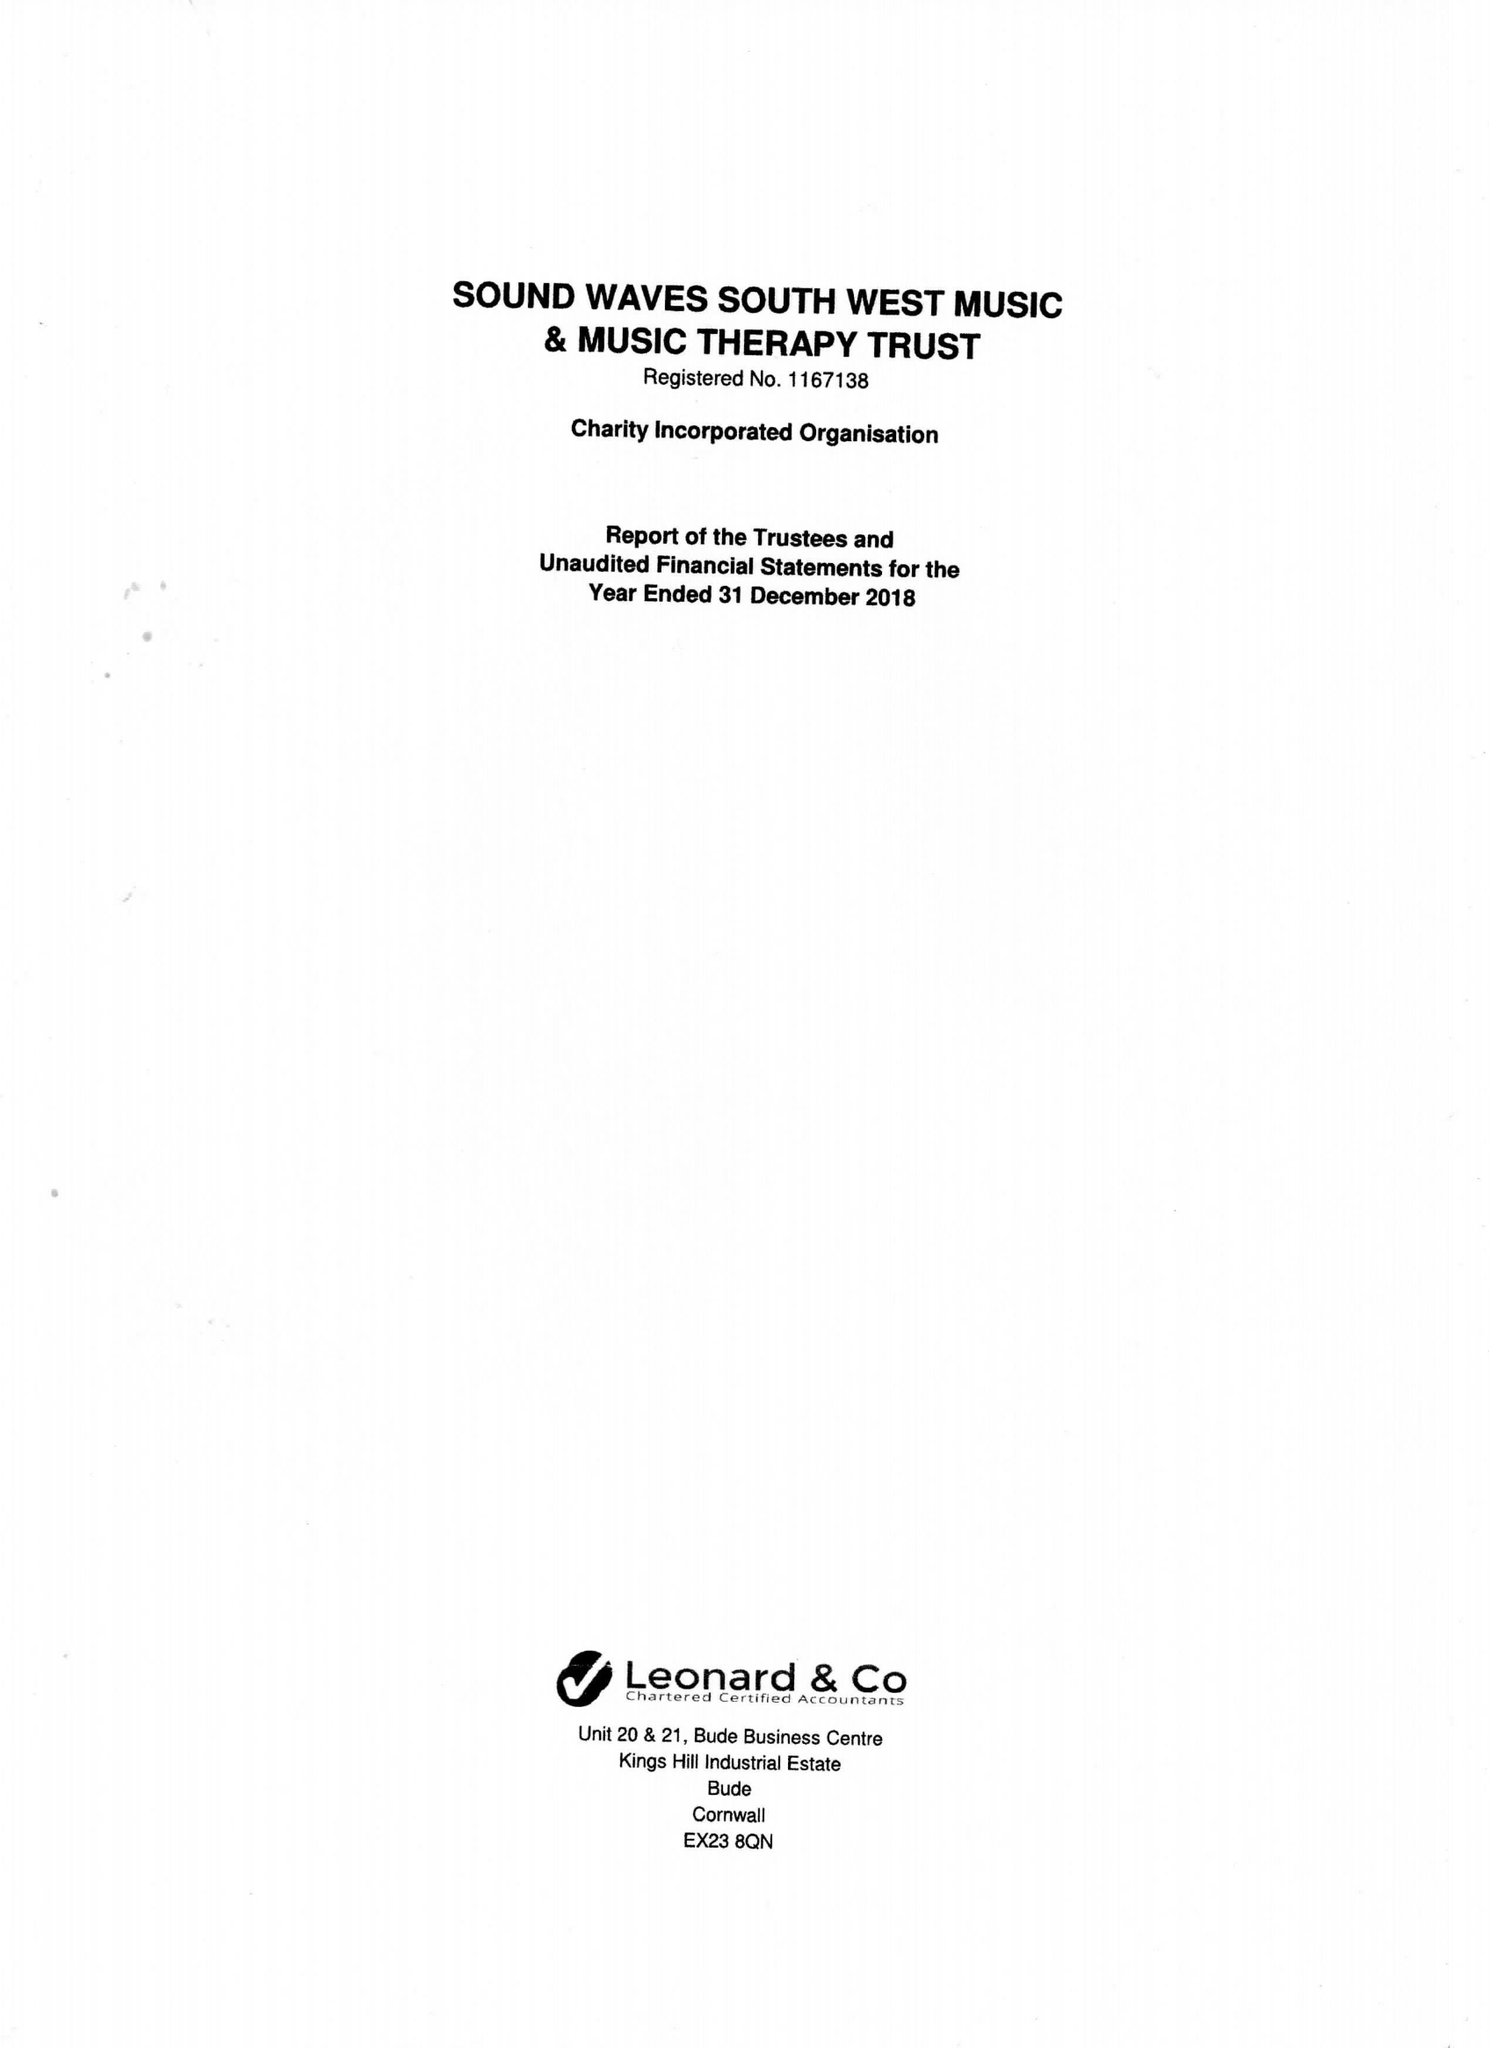What is the value for the report_date?
Answer the question using a single word or phrase. 2018-12-31 